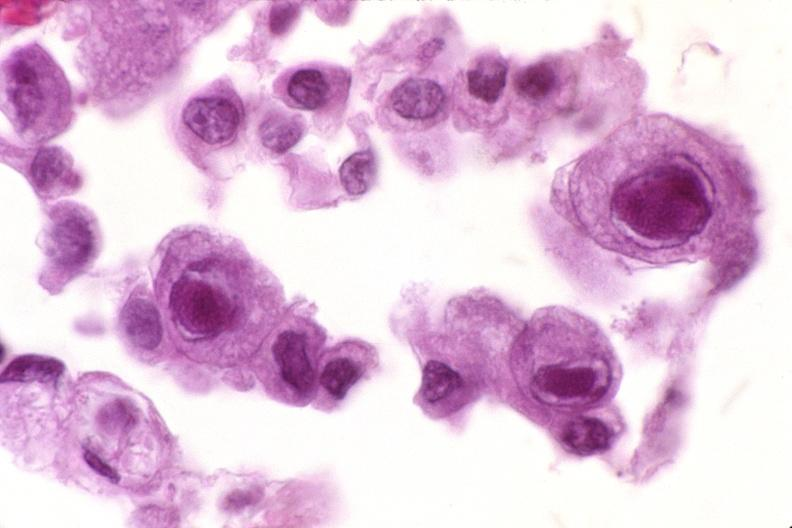does this image show lung, cyomegalovirus pneumonia?
Answer the question using a single word or phrase. Yes 